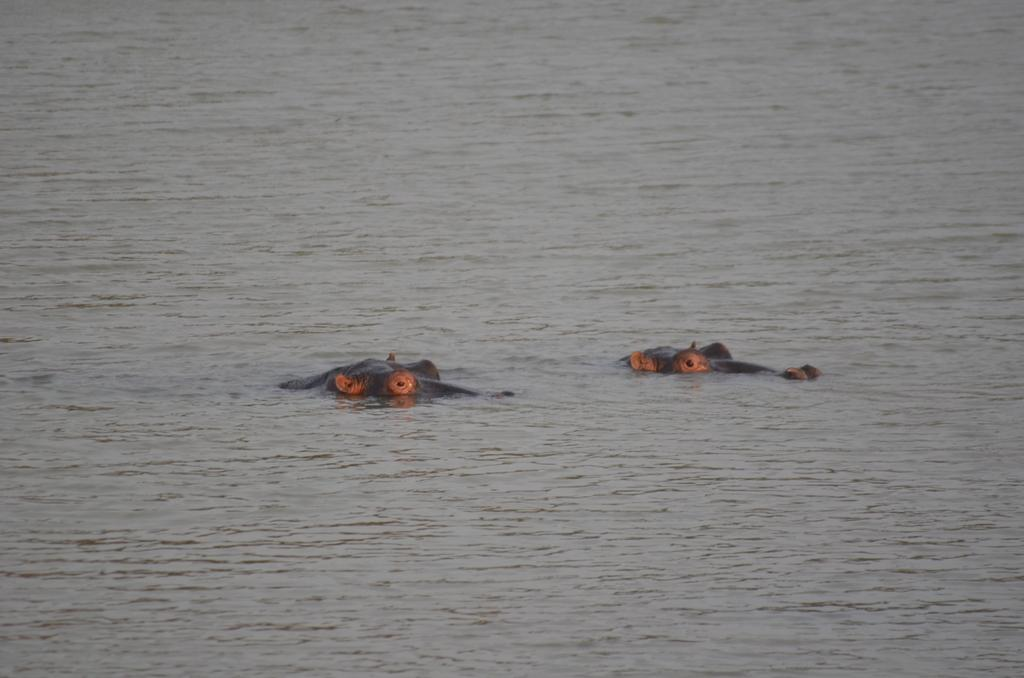What animals are present in the image? There are two hippopotamuses in the image. What are the hippopotamuses doing in the image? The hippopotamuses are swimming in the water. What type of grape can be seen floating next to the hippopotamuses in the image? There are no grapes present in the image; it features two hippopotamuses swimming in the water. How many hippopotamuses and grapes combined are visible in the image? There are two hippopotamuses and no grapes visible in the image, so the total count would be two. 